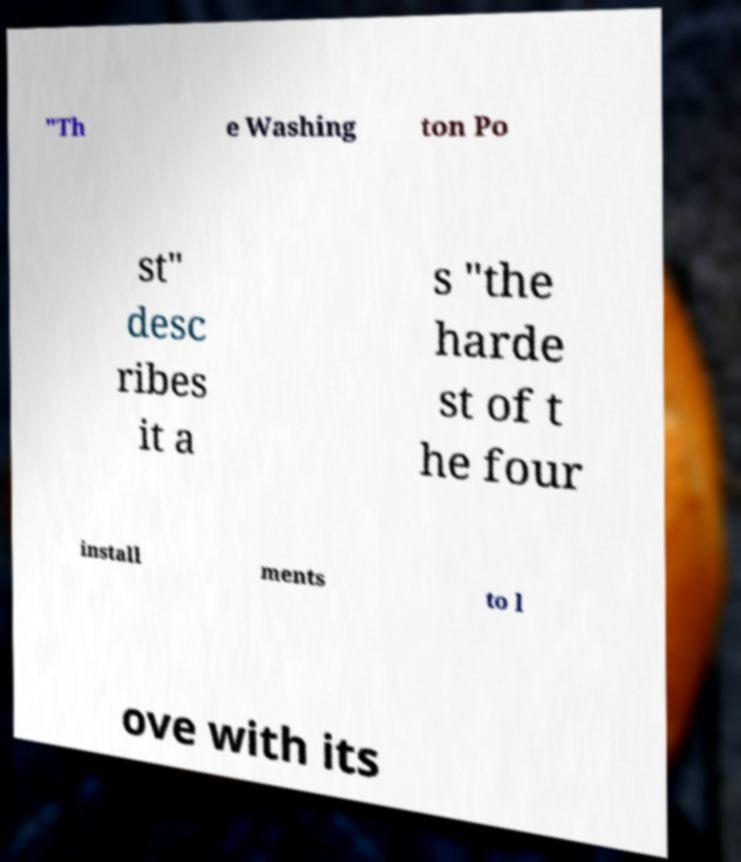Please identify and transcribe the text found in this image. "Th e Washing ton Po st" desc ribes it a s "the harde st of t he four install ments to l ove with its 